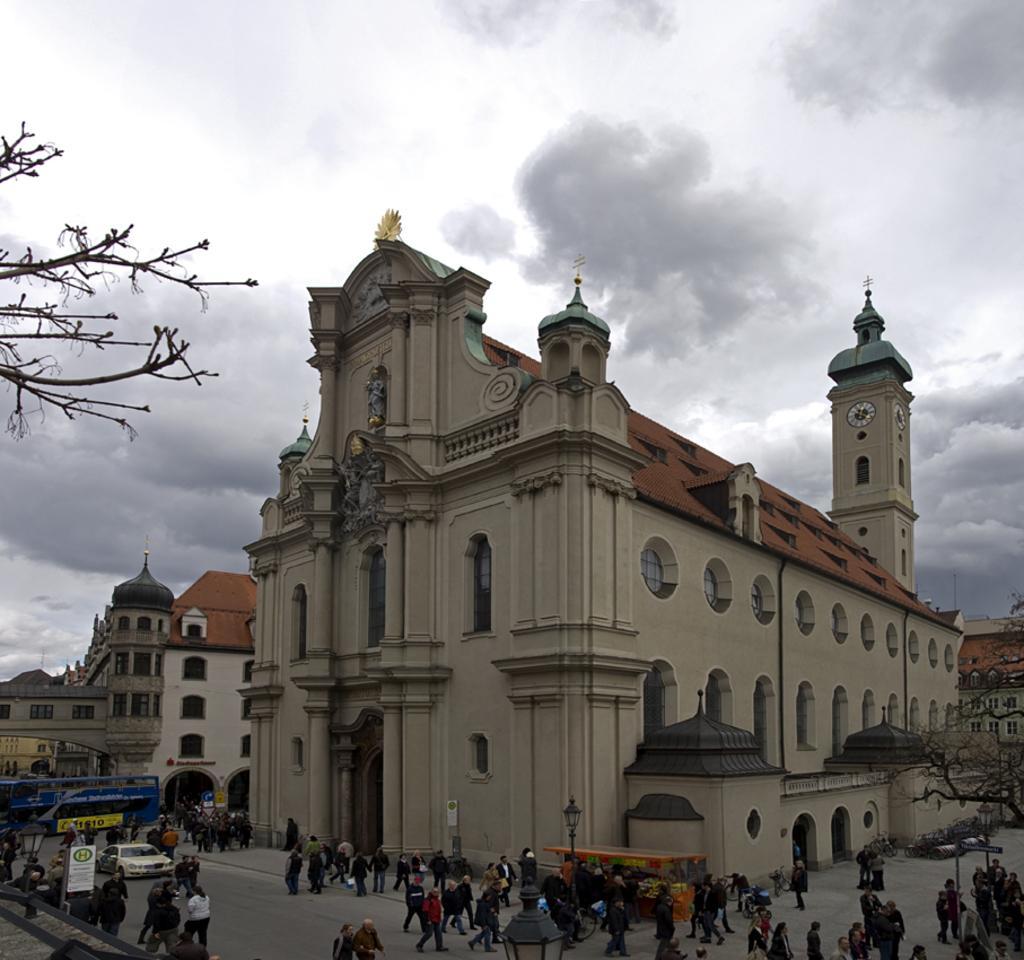Can you describe this image briefly? In this image there are buildings, in front of the buildings there are a few people standing and walking on the road and there are few vehicles. On the left and right side of the image there is a tree. In the background there is the sky. 